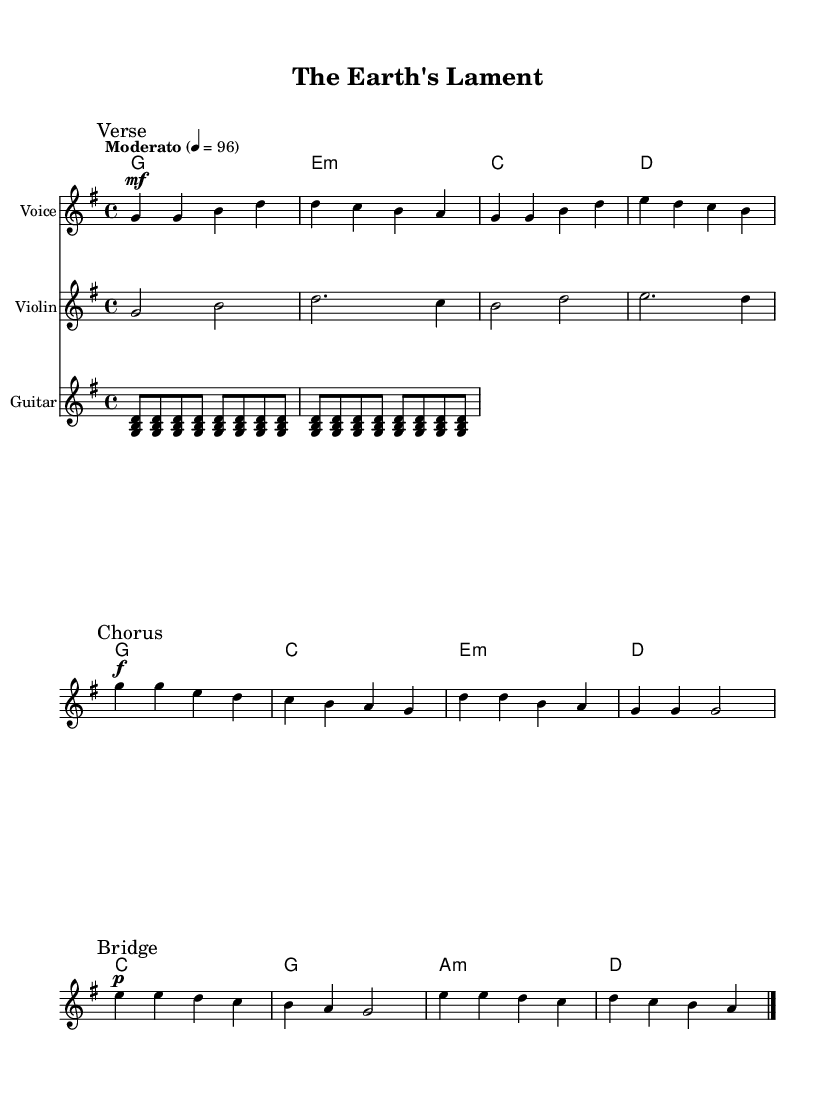What is the key signature of this music? The key signature is G major, which has one sharp (F#). This can be identified by looking at the key signature indicated at the beginning of the staff, which shows one sharp.
Answer: G major What is the time signature of this music? The time signature is 4/4, which means there are four beats in a measure and the quarter note gets one beat. This is indicated at the start of the score.
Answer: 4/4 What is the tempo marking of this piece? The tempo marking is Moderato, which suggests a moderate speed for the performance. This is indicated at the beginning of the score next to the tempo marking.
Answer: Moderato How many measures are in the verse section? The verse section contains four measures, as indicated by the group of notes before the first chorus marking. Each set of notes separated by bar lines represents a measure.
Answer: 4 What dynamics are indicated in the chorus? The dynamics indicated in the chorus are loud (forte), as shown by the "f" marking placed right before the chorus section begins.
Answer: forte What is the first note of the bridge? The first note of the bridge is E. This can be deduced by identifying the notes in the bridge section, starting from the first note after the "Bridge" marking.
Answer: E Identify the instrument that plays the chords in this piece. The instrument that plays the chords is the Guitar, which is indicated by the staff labeled "Guitar" in the score.
Answer: Guitar 